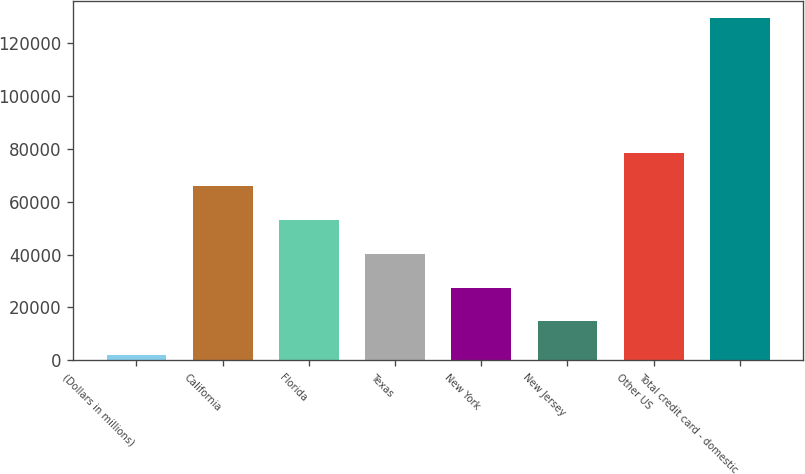Convert chart. <chart><loc_0><loc_0><loc_500><loc_500><bar_chart><fcel>(Dollars in millions)<fcel>California<fcel>Florida<fcel>Texas<fcel>New York<fcel>New Jersey<fcel>Other US<fcel>Total credit card - domestic<nl><fcel>2009<fcel>65825.5<fcel>53062.2<fcel>40298.9<fcel>27535.6<fcel>14772.3<fcel>78588.8<fcel>129642<nl></chart> 